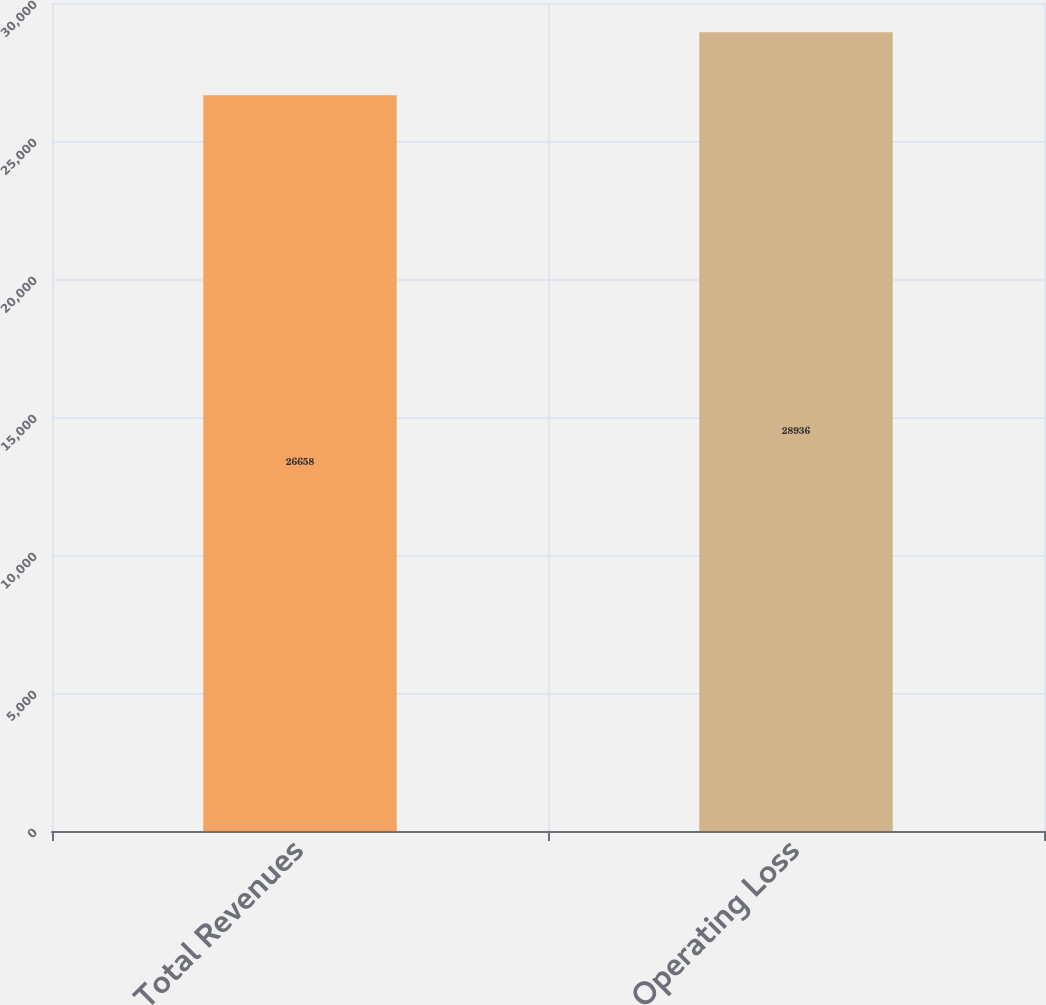Convert chart. <chart><loc_0><loc_0><loc_500><loc_500><bar_chart><fcel>Total Revenues<fcel>Operating Loss<nl><fcel>26658<fcel>28936<nl></chart> 